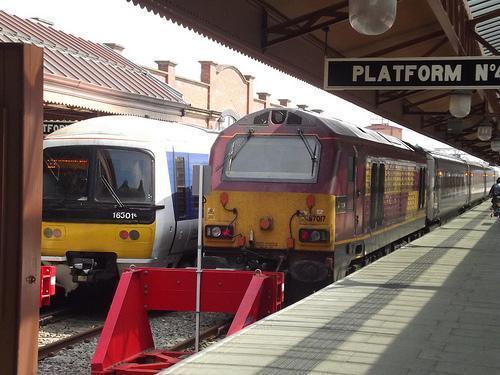How many trains are there?
Give a very brief answer. 2. 